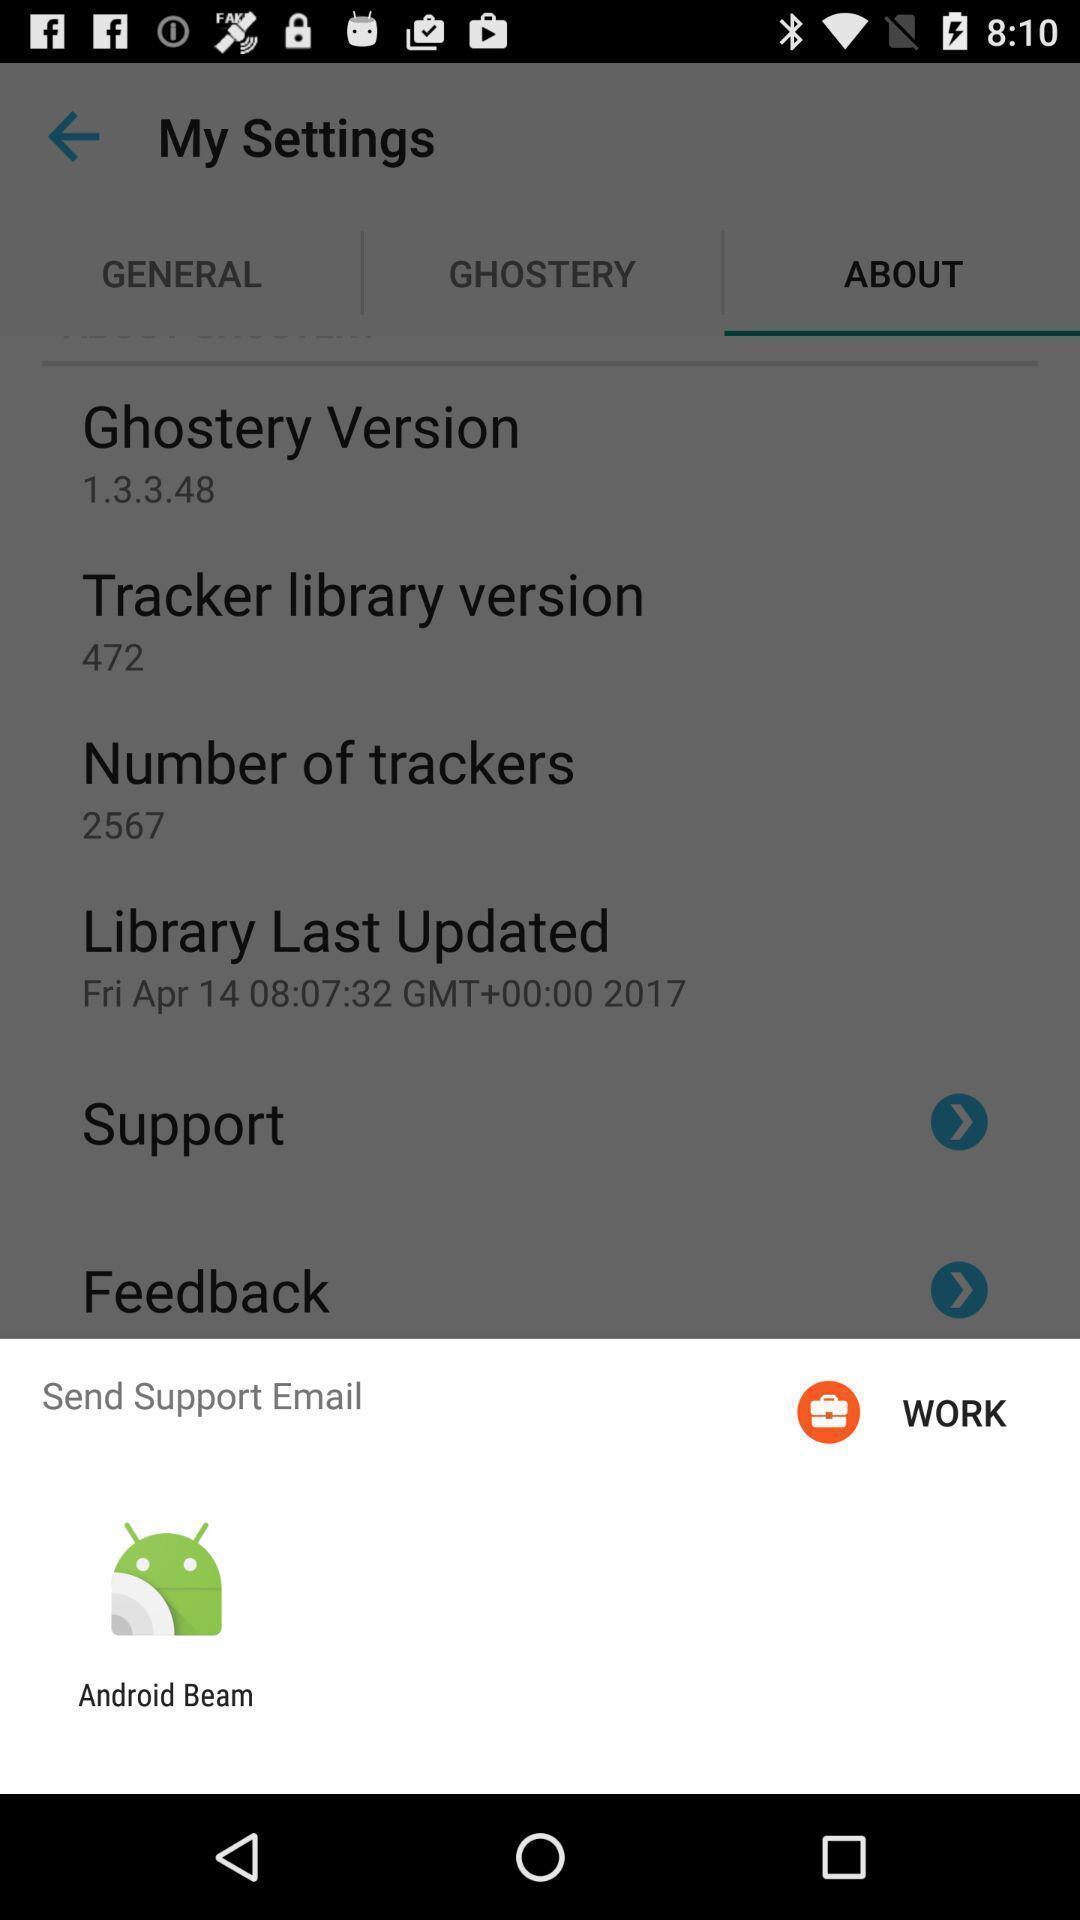Summarize the information in this screenshot. Popup of application to share the mail in mobile. 